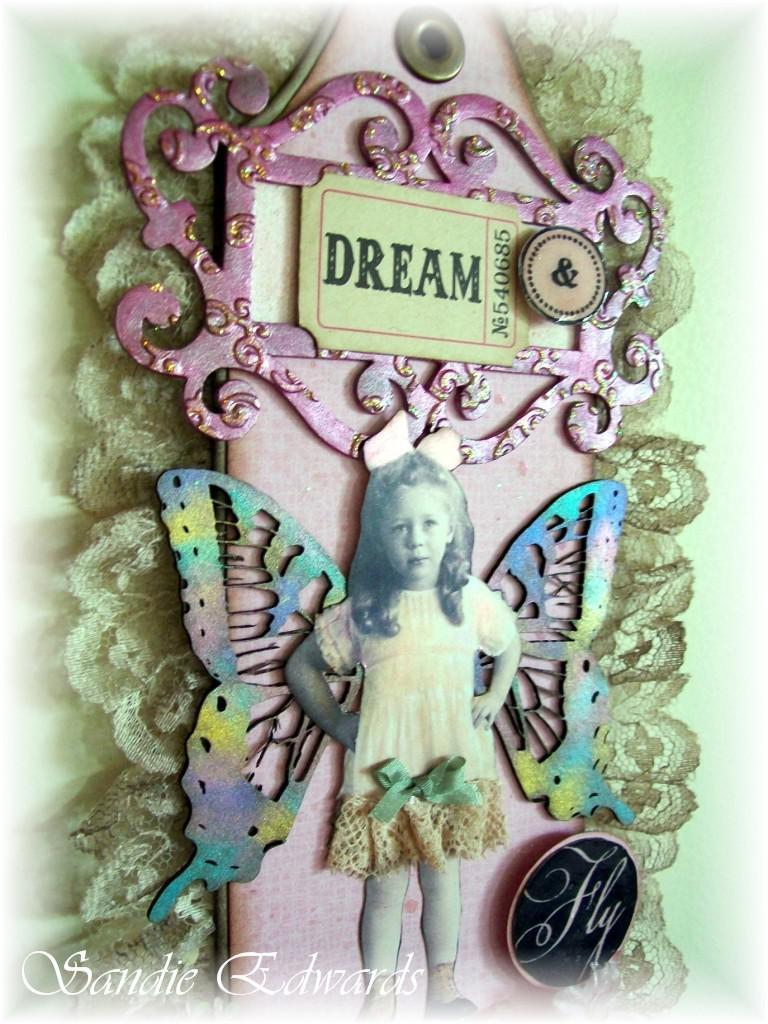<image>
Provide a brief description of the given image. A butterfly craft thing that says dream and fly on it. 